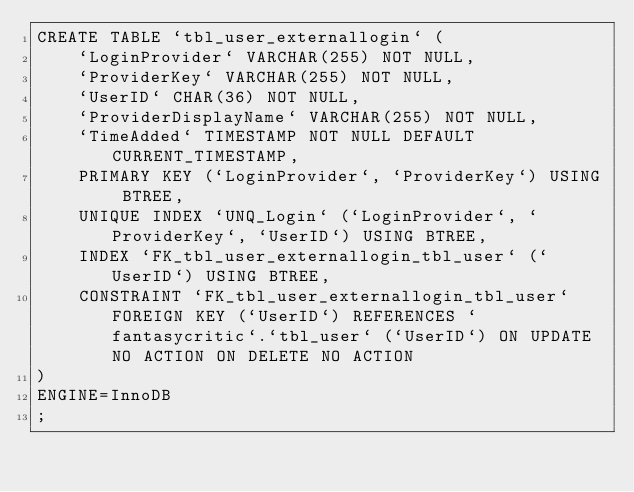Convert code to text. <code><loc_0><loc_0><loc_500><loc_500><_SQL_>CREATE TABLE `tbl_user_externallogin` (
	`LoginProvider` VARCHAR(255) NOT NULL,
	`ProviderKey` VARCHAR(255) NOT NULL,
	`UserID` CHAR(36) NOT NULL,
	`ProviderDisplayName` VARCHAR(255) NOT NULL,
	`TimeAdded` TIMESTAMP NOT NULL DEFAULT CURRENT_TIMESTAMP,
	PRIMARY KEY (`LoginProvider`, `ProviderKey`) USING BTREE,
	UNIQUE INDEX `UNQ_Login` (`LoginProvider`, `ProviderKey`, `UserID`) USING BTREE,
	INDEX `FK_tbl_user_externallogin_tbl_user` (`UserID`) USING BTREE,
	CONSTRAINT `FK_tbl_user_externallogin_tbl_user` FOREIGN KEY (`UserID`) REFERENCES `fantasycritic`.`tbl_user` (`UserID`) ON UPDATE NO ACTION ON DELETE NO ACTION
)
ENGINE=InnoDB
;
</code> 